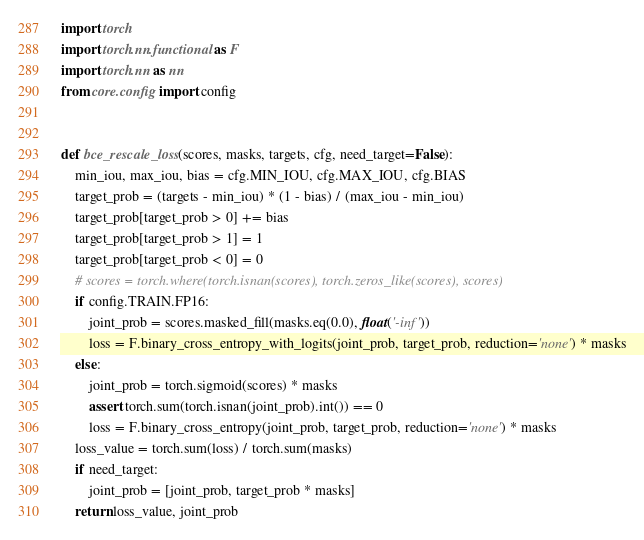<code> <loc_0><loc_0><loc_500><loc_500><_Python_>import torch
import torch.nn.functional as F
import torch.nn as nn
from core.config import config


def bce_rescale_loss(scores, masks, targets, cfg, need_target=False):
    min_iou, max_iou, bias = cfg.MIN_IOU, cfg.MAX_IOU, cfg.BIAS
    target_prob = (targets - min_iou) * (1 - bias) / (max_iou - min_iou)
    target_prob[target_prob > 0] += bias
    target_prob[target_prob > 1] = 1
    target_prob[target_prob < 0] = 0
    # scores = torch.where(torch.isnan(scores), torch.zeros_like(scores), scores)
    if config.TRAIN.FP16:
        joint_prob = scores.masked_fill(masks.eq(0.0), float('-inf'))
        loss = F.binary_cross_entropy_with_logits(joint_prob, target_prob, reduction='none') * masks
    else:
        joint_prob = torch.sigmoid(scores) * masks
        assert torch.sum(torch.isnan(joint_prob).int()) == 0
        loss = F.binary_cross_entropy(joint_prob, target_prob, reduction='none') * masks
    loss_value = torch.sum(loss) / torch.sum(masks)
    if need_target:
        joint_prob = [joint_prob, target_prob * masks]
    return loss_value, joint_prob</code> 